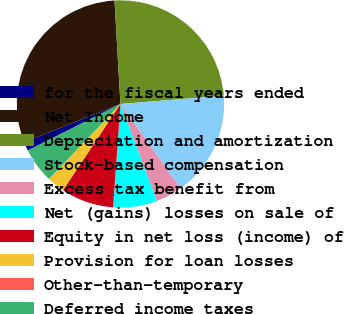Convert chart to OTSL. <chart><loc_0><loc_0><loc_500><loc_500><pie_chart><fcel>for the fiscal years ended<fcel>Net Income<fcel>Depreciation and amortization<fcel>Stock-based compensation<fcel>Excess tax benefit from<fcel>Net (gains) losses on sale of<fcel>Equity in net loss (income) of<fcel>Provision for loan losses<fcel>Other-than-temporary<fcel>Deferred income taxes<nl><fcel>1.38%<fcel>30.11%<fcel>24.64%<fcel>16.43%<fcel>4.12%<fcel>6.85%<fcel>8.22%<fcel>2.75%<fcel>0.01%<fcel>5.48%<nl></chart> 